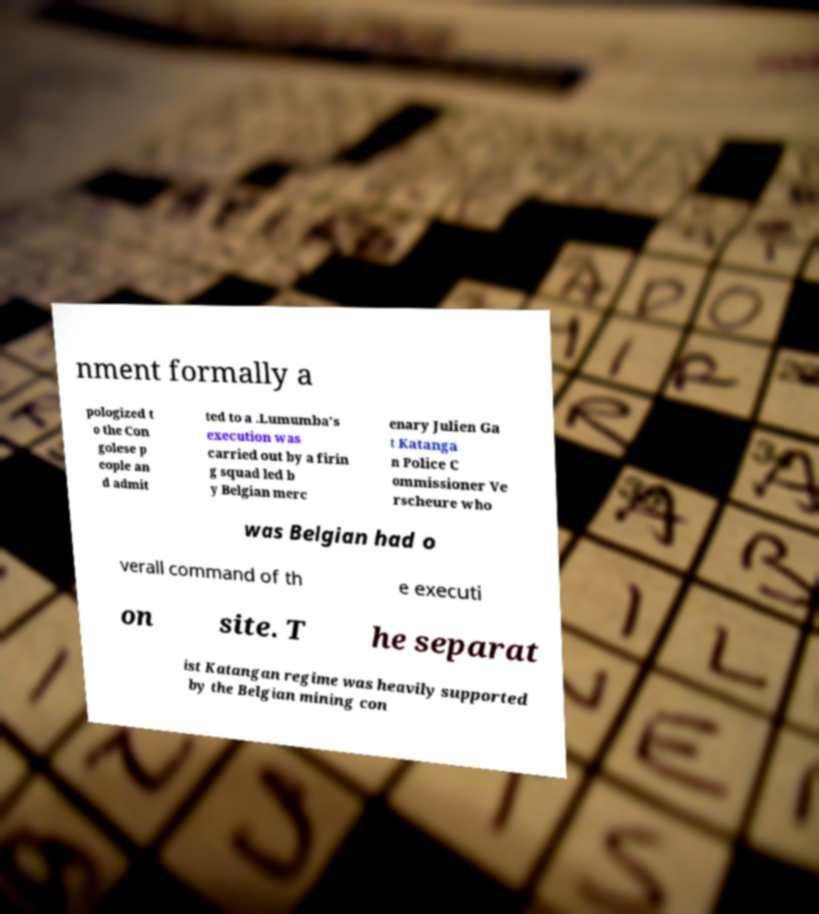Could you assist in decoding the text presented in this image and type it out clearly? nment formally a pologized t o the Con golese p eople an d admit ted to a .Lumumba's execution was carried out by a firin g squad led b y Belgian merc enary Julien Ga t Katanga n Police C ommissioner Ve rscheure who was Belgian had o verall command of th e executi on site. T he separat ist Katangan regime was heavily supported by the Belgian mining con 